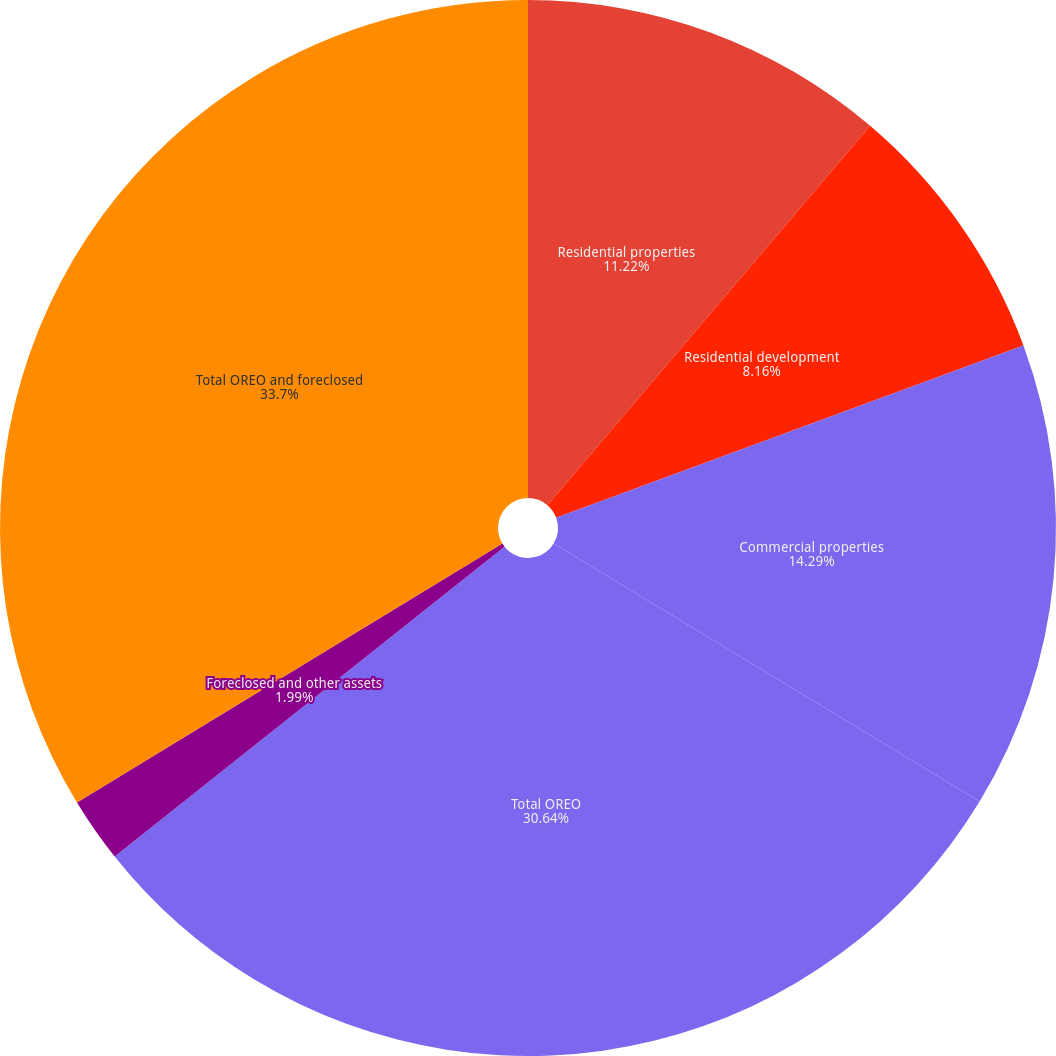Convert chart to OTSL. <chart><loc_0><loc_0><loc_500><loc_500><pie_chart><fcel>Residential properties<fcel>Residential development<fcel>Commercial properties<fcel>Total OREO<fcel>Foreclosed and other assets<fcel>Total OREO and foreclosed<nl><fcel>11.22%<fcel>8.16%<fcel>14.29%<fcel>30.64%<fcel>1.99%<fcel>33.7%<nl></chart> 